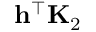<formula> <loc_0><loc_0><loc_500><loc_500>h ^ { \top } K _ { 2 }</formula> 